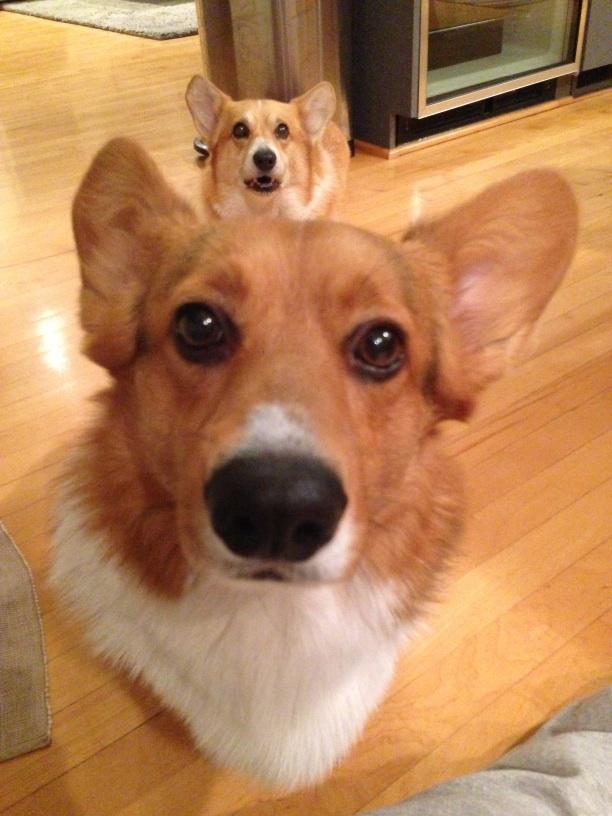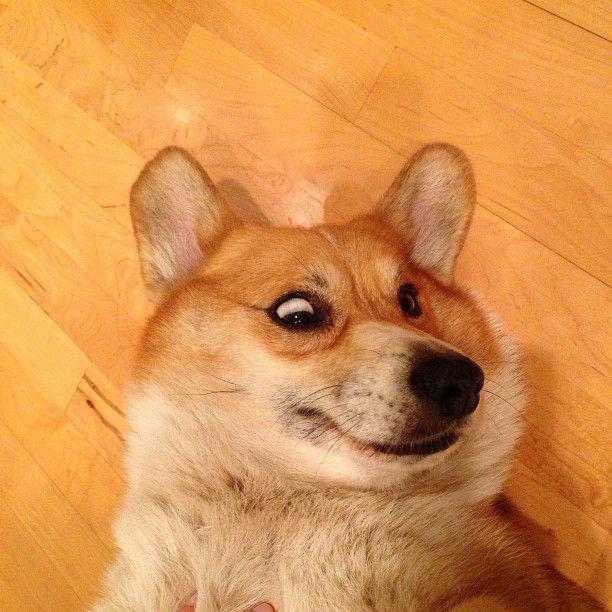The first image is the image on the left, the second image is the image on the right. Evaluate the accuracy of this statement regarding the images: "There are at most four dogs.". Is it true? Answer yes or no. Yes. The first image is the image on the left, the second image is the image on the right. Given the left and right images, does the statement "There are no more than two dogs in the left image." hold true? Answer yes or no. Yes. 